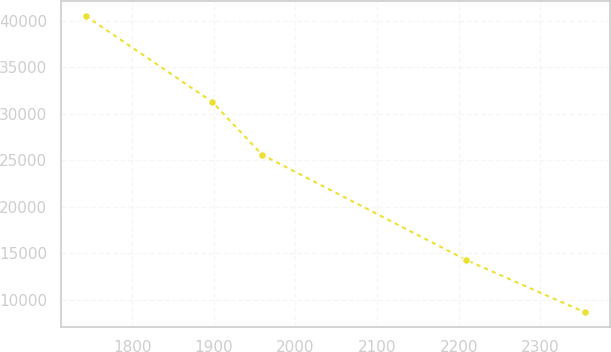Convert chart to OTSL. <chart><loc_0><loc_0><loc_500><loc_500><line_chart><ecel><fcel>Unnamed: 1<nl><fcel>1742.88<fcel>40519.7<nl><fcel>1897.89<fcel>31277.3<nl><fcel>1959.07<fcel>25587.5<nl><fcel>2208.65<fcel>14286.4<nl><fcel>2354.68<fcel>8624.49<nl></chart> 